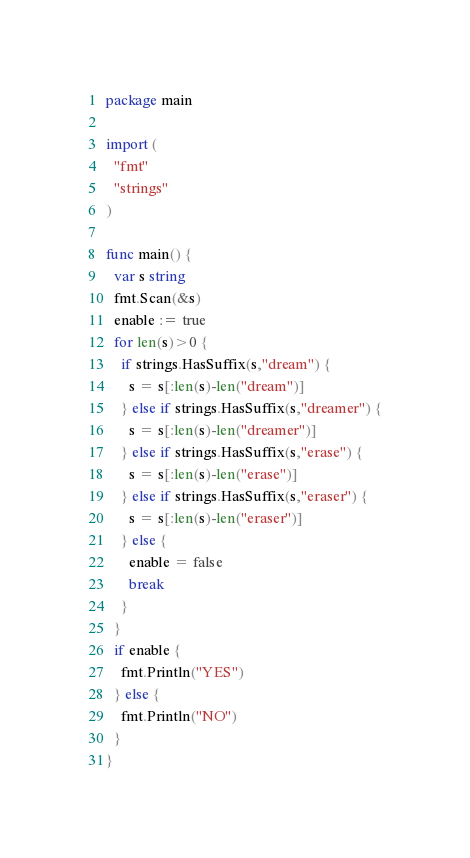Convert code to text. <code><loc_0><loc_0><loc_500><loc_500><_Go_>package main

import (
  "fmt"
  "strings"
)

func main() {
  var s string
  fmt.Scan(&s)
  enable := true
  for len(s)>0 {
	if strings.HasSuffix(s,"dream") {
	  s = s[:len(s)-len("dream")]
	} else if strings.HasSuffix(s,"dreamer") {
	  s = s[:len(s)-len("dreamer")]
	} else if strings.HasSuffix(s,"erase") {
	  s = s[:len(s)-len("erase")]
	} else if strings.HasSuffix(s,"eraser") {
	  s = s[:len(s)-len("eraser")]
	} else {
	  enable = false
	  break
	}
  }
  if enable {
	fmt.Println("YES")
  } else {
	fmt.Println("NO")
  }
}
</code> 